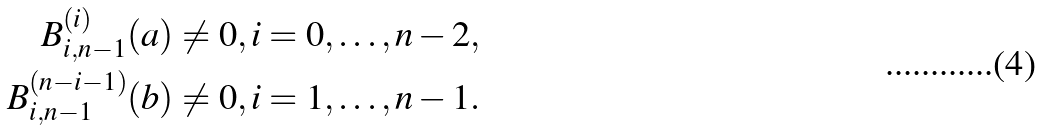<formula> <loc_0><loc_0><loc_500><loc_500>B _ { i , n - 1 } ^ { ( i ) } ( a ) \neq 0 , i = 0 , \dots , n - 2 , \\ B _ { i , n - 1 } ^ { ( n - i - 1 ) } ( b ) \neq 0 , i = 1 , \dots , n - 1 .</formula> 